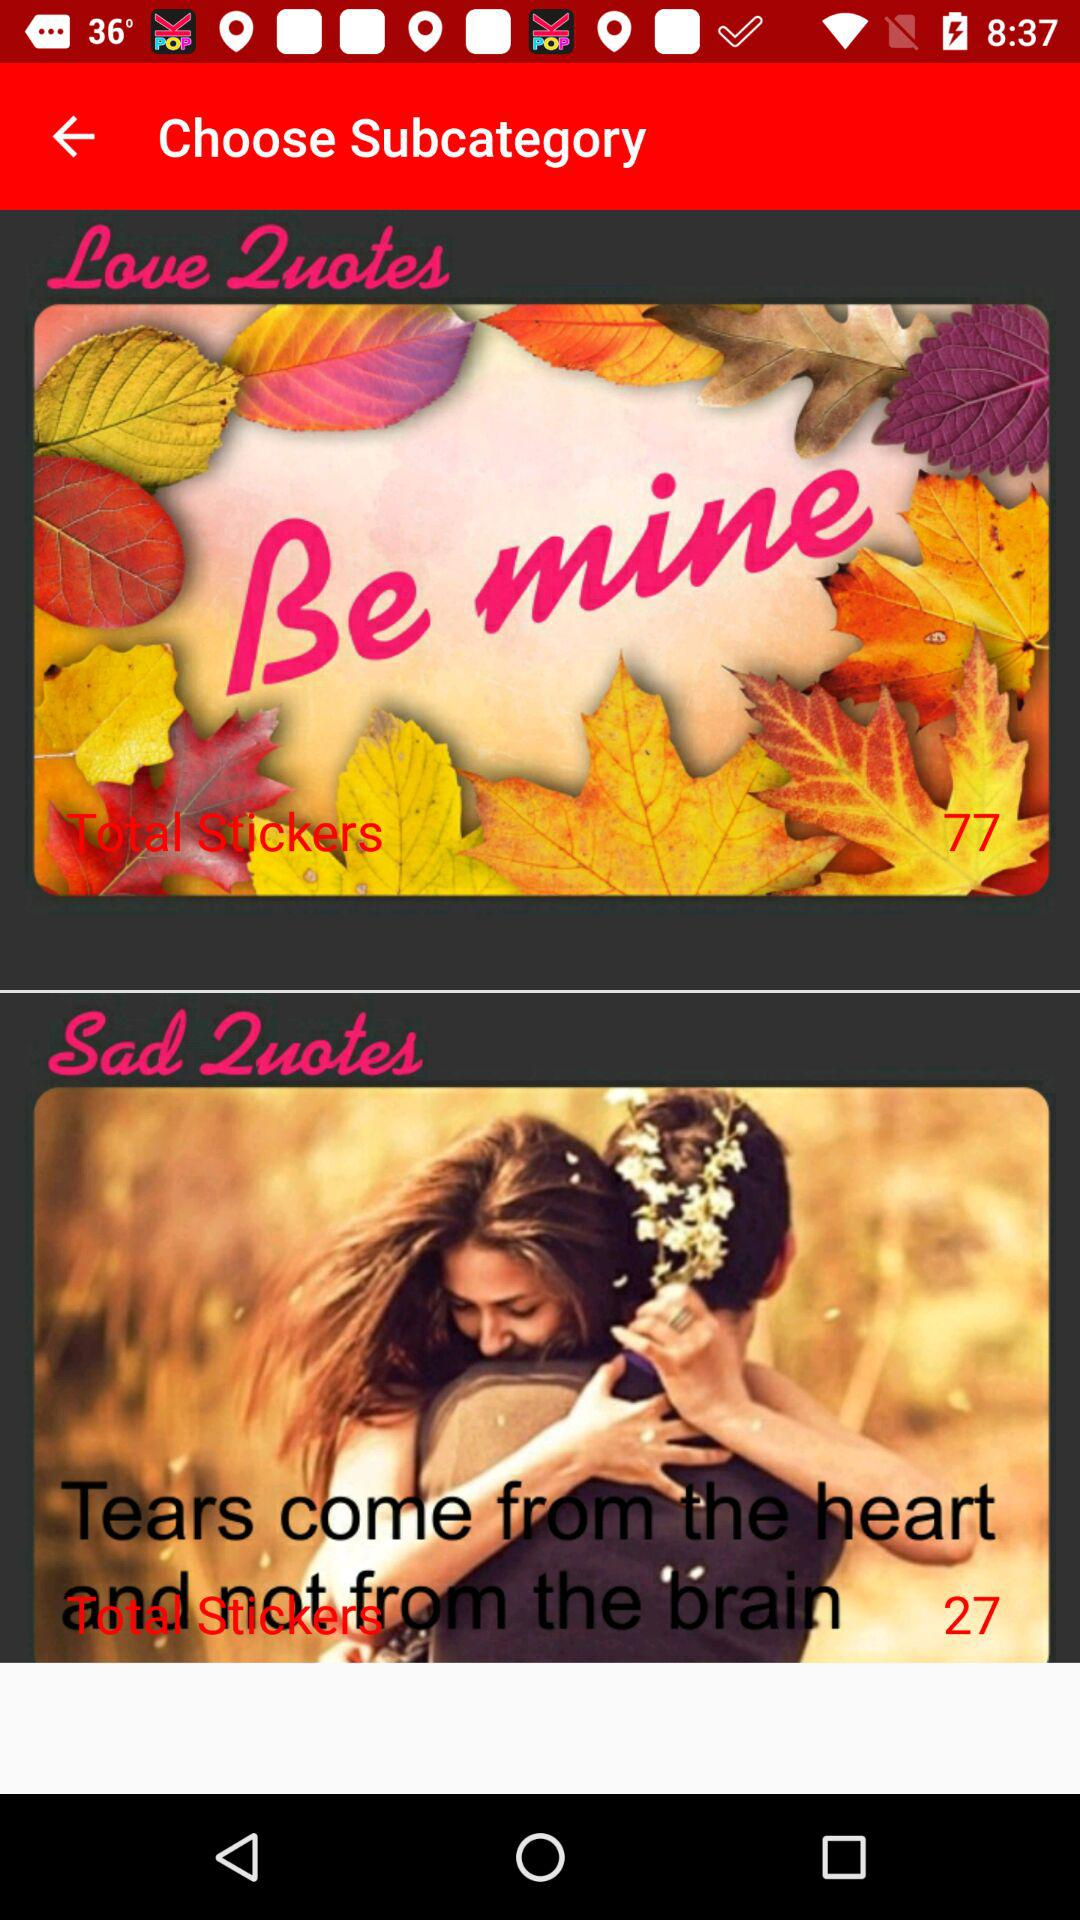How many stickers are there for "Sad quotes"? There are 27 stickers for "Sad quotes". 